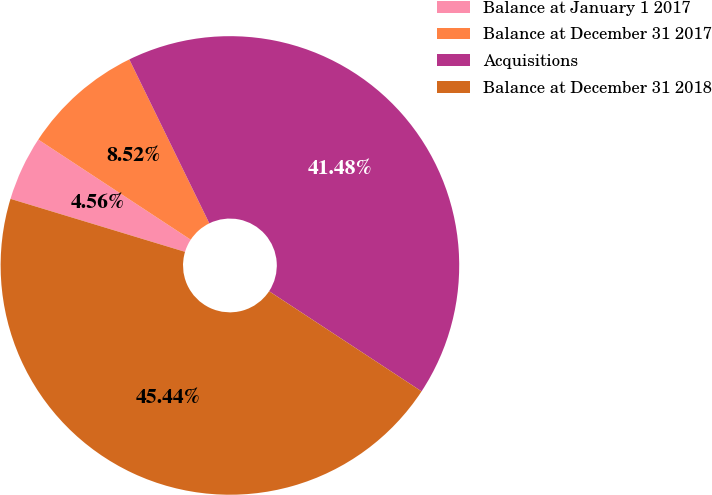Convert chart. <chart><loc_0><loc_0><loc_500><loc_500><pie_chart><fcel>Balance at January 1 2017<fcel>Balance at December 31 2017<fcel>Acquisitions<fcel>Balance at December 31 2018<nl><fcel>4.56%<fcel>8.52%<fcel>41.48%<fcel>45.44%<nl></chart> 